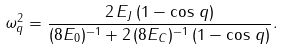<formula> <loc_0><loc_0><loc_500><loc_500>\omega _ { q } ^ { 2 } = \frac { 2 \, E _ { J } \, ( 1 - \cos \, q ) } { ( 8 E _ { 0 } ) ^ { - 1 } + 2 \, ( 8 E _ { C } ) ^ { - 1 } \, ( 1 - \cos \, q ) } .</formula> 